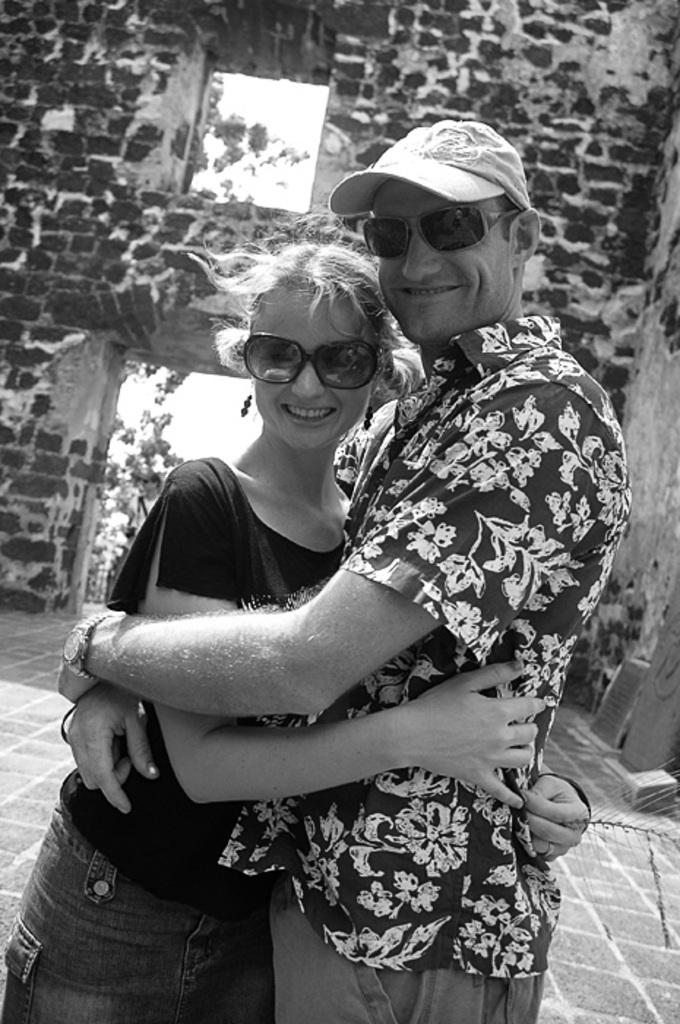How many people are in the image? There are two people in the image. What are the people doing in the image? The people are smiling in the image. What are the people wearing on their faces? The people are wearing goggles in the image. What can be seen in the background of the image? There is a brick wall and a tree in the background of the image, as well as other unspecified things. What type of crime is being committed by the ladybug in the image? There is no ladybug present in the image, and therefore no crime can be committed by a ladybug. How many cattle are visible in the image? There are no cattle present in the image. 